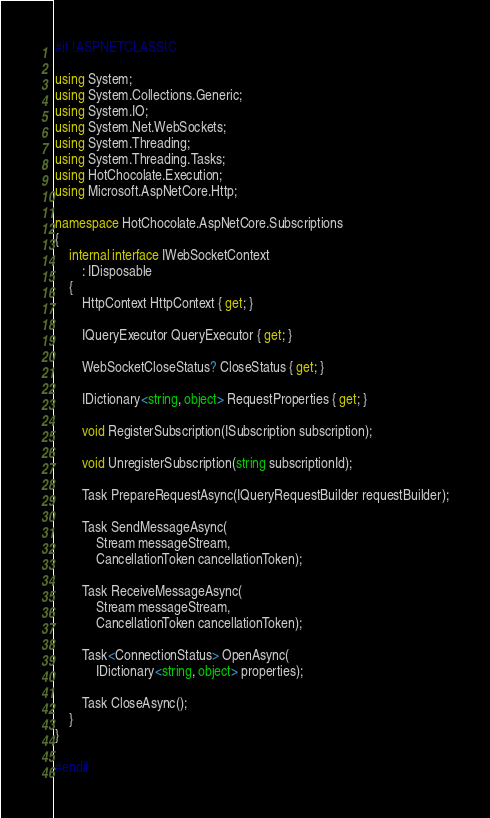Convert code to text. <code><loc_0><loc_0><loc_500><loc_500><_C#_>#if !ASPNETCLASSIC

using System;
using System.Collections.Generic;
using System.IO;
using System.Net.WebSockets;
using System.Threading;
using System.Threading.Tasks;
using HotChocolate.Execution;
using Microsoft.AspNetCore.Http;

namespace HotChocolate.AspNetCore.Subscriptions
{
    internal interface IWebSocketContext
        : IDisposable
    {
        HttpContext HttpContext { get; }

        IQueryExecutor QueryExecutor { get; }

        WebSocketCloseStatus? CloseStatus { get; }

        IDictionary<string, object> RequestProperties { get; }

        void RegisterSubscription(ISubscription subscription);

        void UnregisterSubscription(string subscriptionId);

        Task PrepareRequestAsync(IQueryRequestBuilder requestBuilder);

        Task SendMessageAsync(
            Stream messageStream,
            CancellationToken cancellationToken);

        Task ReceiveMessageAsync(
            Stream messageStream,
            CancellationToken cancellationToken);

        Task<ConnectionStatus> OpenAsync(
            IDictionary<string, object> properties);

        Task CloseAsync();
    }
}

#endif
</code> 